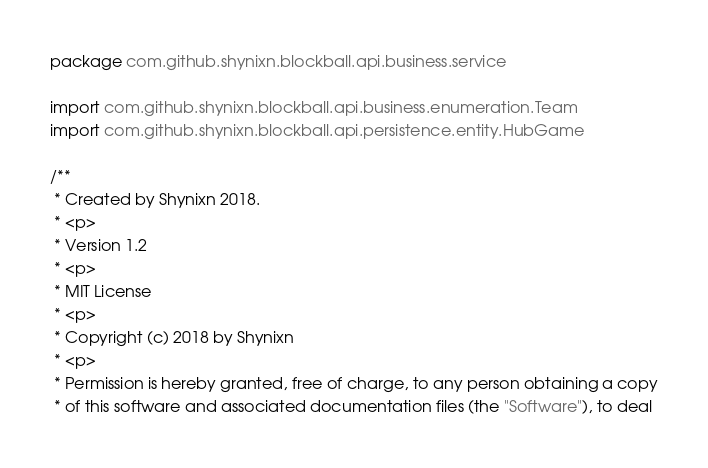Convert code to text. <code><loc_0><loc_0><loc_500><loc_500><_Kotlin_>package com.github.shynixn.blockball.api.business.service

import com.github.shynixn.blockball.api.business.enumeration.Team
import com.github.shynixn.blockball.api.persistence.entity.HubGame

/**
 * Created by Shynixn 2018.
 * <p>
 * Version 1.2
 * <p>
 * MIT License
 * <p>
 * Copyright (c) 2018 by Shynixn
 * <p>
 * Permission is hereby granted, free of charge, to any person obtaining a copy
 * of this software and associated documentation files (the "Software"), to deal</code> 